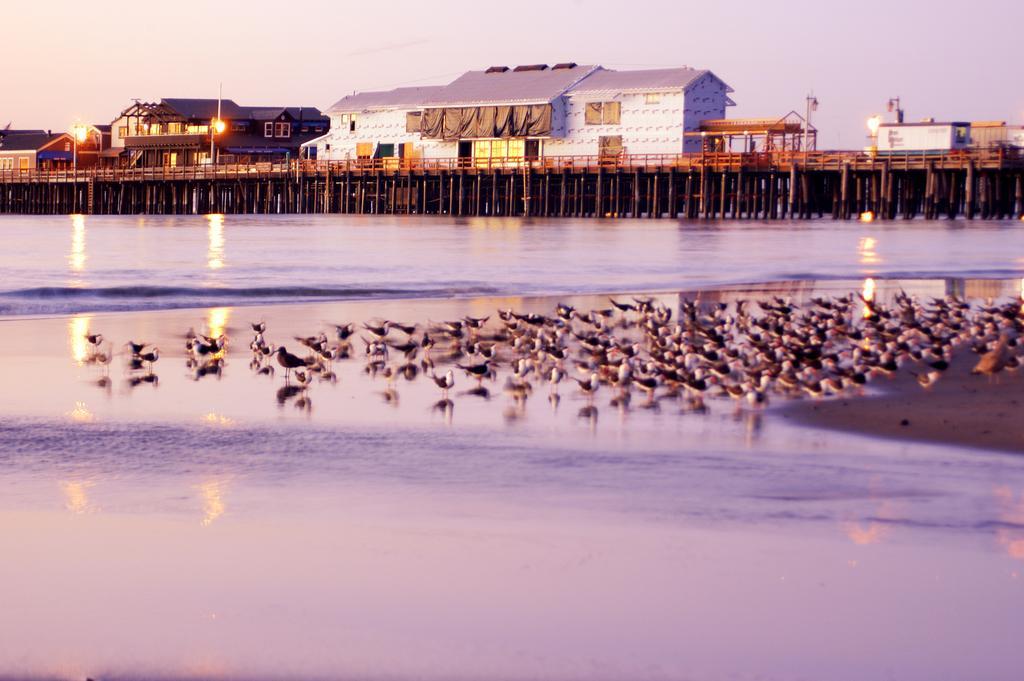How would you summarize this image in a sentence or two? In this image we can see birds on the water and on the sand. In the background there are houses on the bridge and we can see light poles, windows, roofs and sky. 